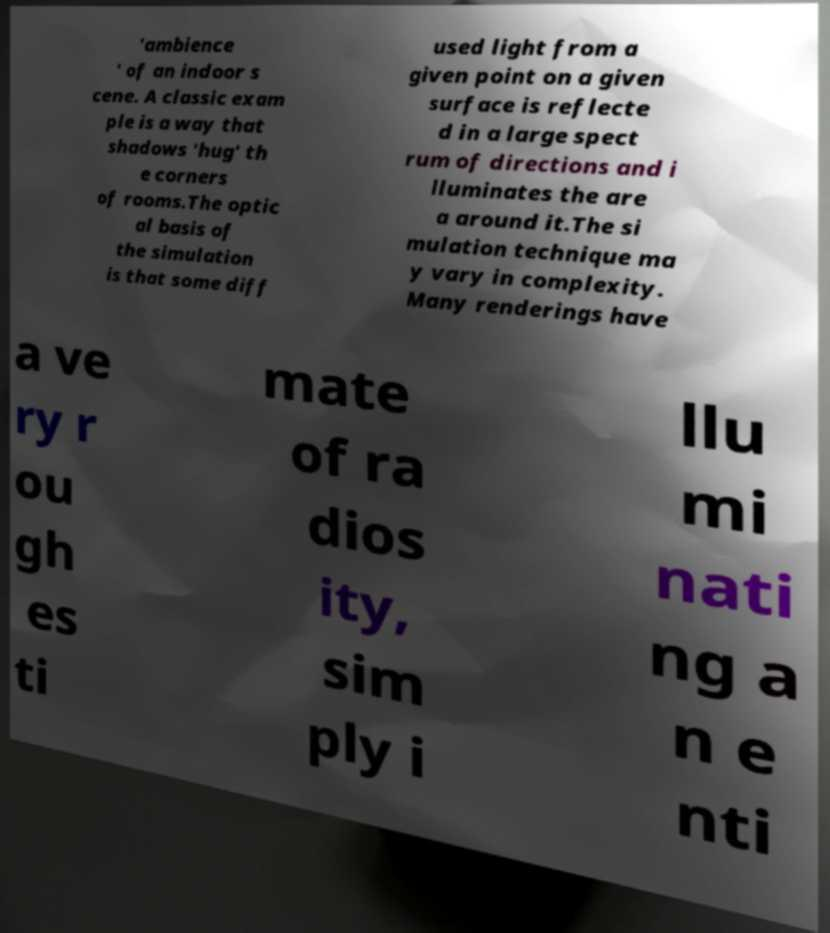Can you read and provide the text displayed in the image?This photo seems to have some interesting text. Can you extract and type it out for me? 'ambience ' of an indoor s cene. A classic exam ple is a way that shadows 'hug' th e corners of rooms.The optic al basis of the simulation is that some diff used light from a given point on a given surface is reflecte d in a large spect rum of directions and i lluminates the are a around it.The si mulation technique ma y vary in complexity. Many renderings have a ve ry r ou gh es ti mate of ra dios ity, sim ply i llu mi nati ng a n e nti 